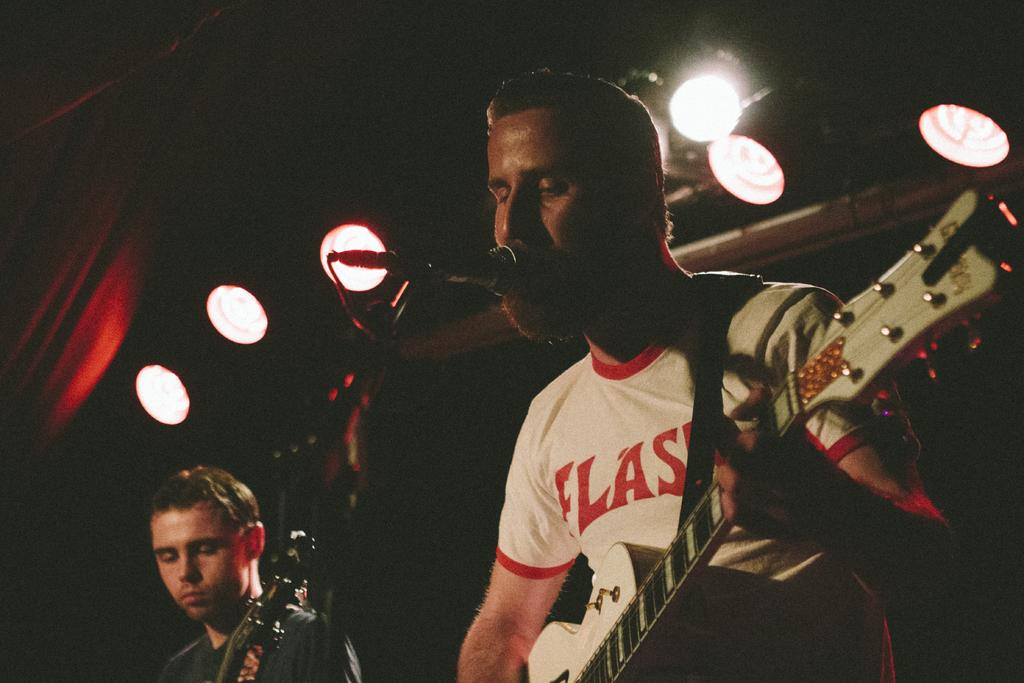How many people are in the image? There are two men in the image. What are the men holding in the image? Both men are holding guitars. What type of copper material is being used by the men in the image? There is no mention of copper or any copper material in the image; the men are holding guitars. Are the men depicted as slaves in the image? There is no indication of slavery or any slave-related context in the image; the men are simply holding guitars. 